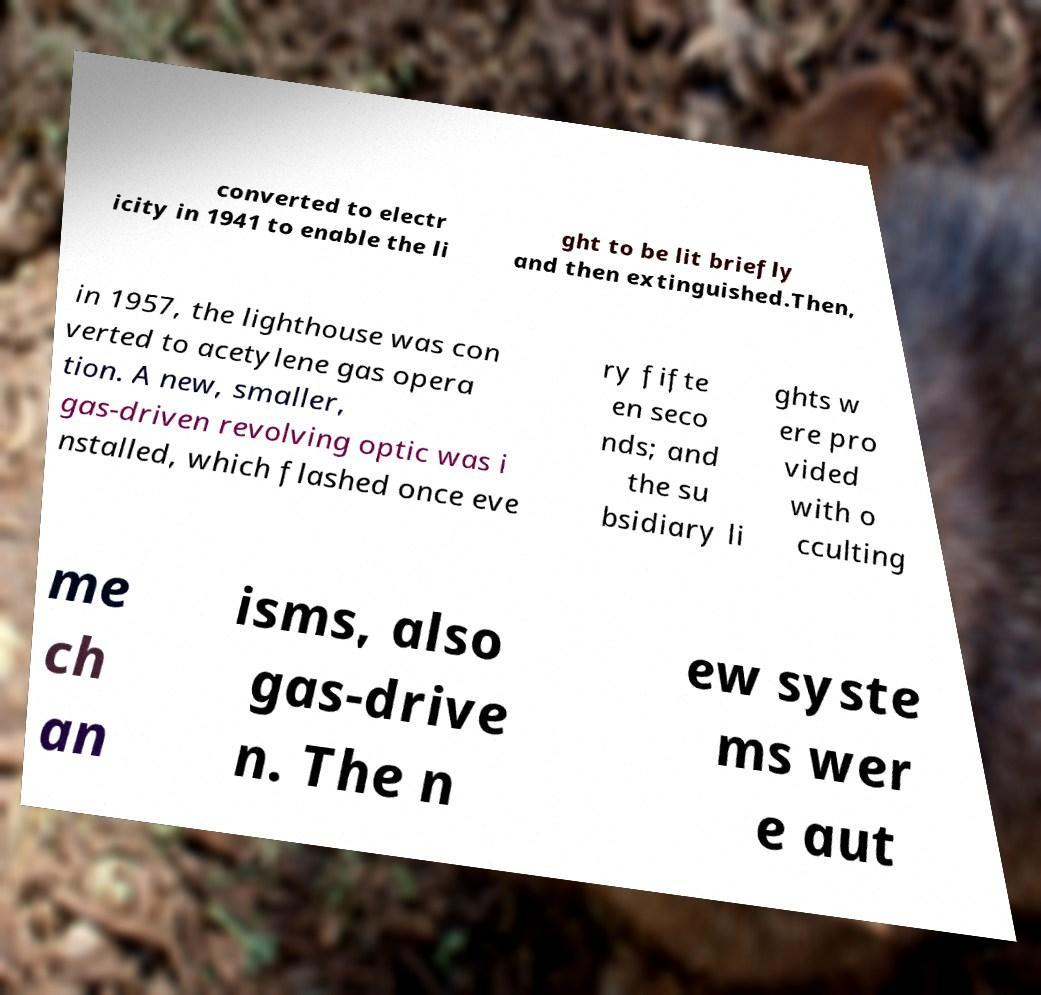Please identify and transcribe the text found in this image. converted to electr icity in 1941 to enable the li ght to be lit briefly and then extinguished.Then, in 1957, the lighthouse was con verted to acetylene gas opera tion. A new, smaller, gas-driven revolving optic was i nstalled, which flashed once eve ry fifte en seco nds; and the su bsidiary li ghts w ere pro vided with o cculting me ch an isms, also gas-drive n. The n ew syste ms wer e aut 